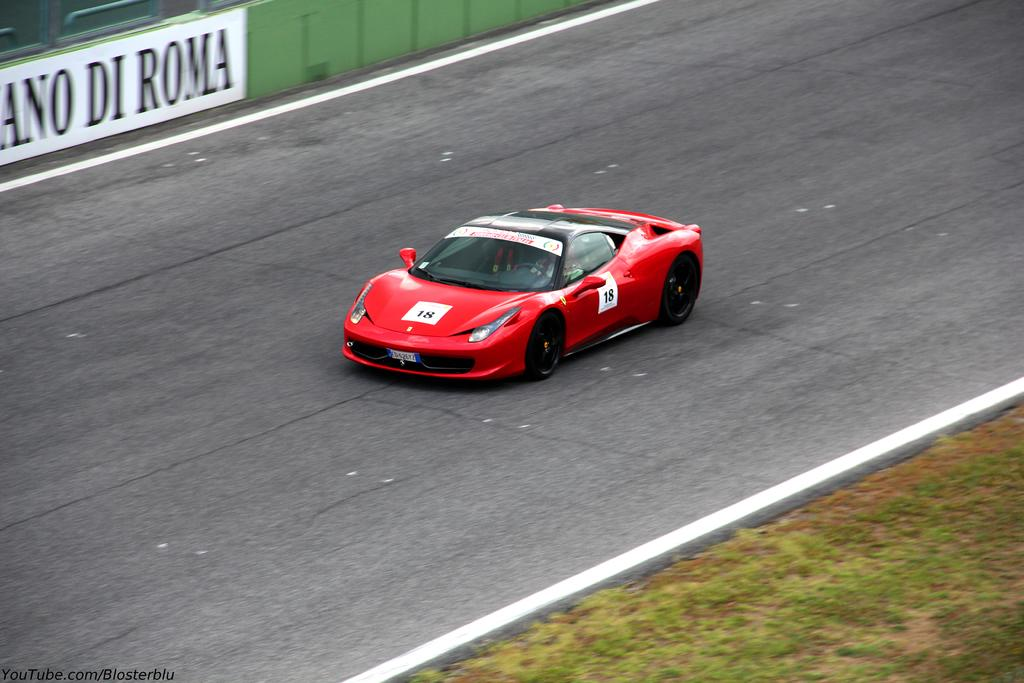What is the person in the image doing? The person is sitting in a sports car. Where is the car located? The car is on the road. What is behind the car in the image? There is a board behind the car. What type of vegetation is on the right side of the car? There is grass on the right side of the car. How many yams are visible in the image? There are no yams present in the image. What is the chin of the person sitting in the car doing in the image? The person's chin is not visible in the image, so it cannot be determined what it is doing. 